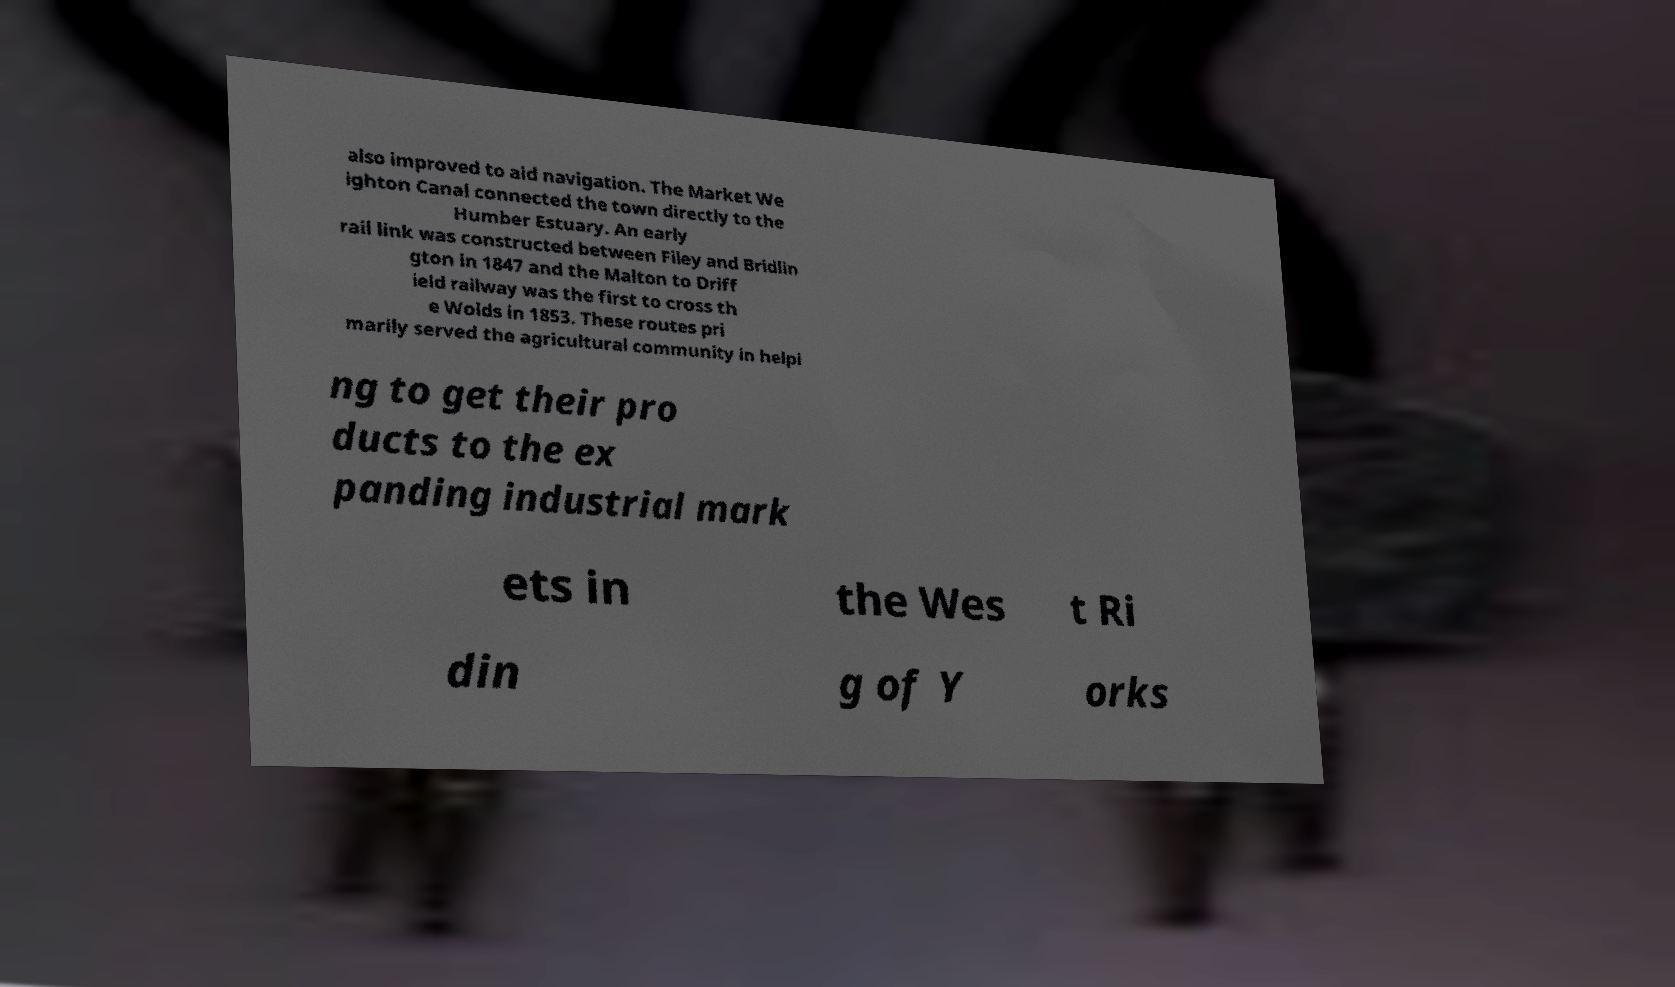Can you read and provide the text displayed in the image?This photo seems to have some interesting text. Can you extract and type it out for me? also improved to aid navigation. The Market We ighton Canal connected the town directly to the Humber Estuary. An early rail link was constructed between Filey and Bridlin gton in 1847 and the Malton to Driff ield railway was the first to cross th e Wolds in 1853. These routes pri marily served the agricultural community in helpi ng to get their pro ducts to the ex panding industrial mark ets in the Wes t Ri din g of Y orks 